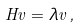<formula> <loc_0><loc_0><loc_500><loc_500>H v = \lambda v \, ,</formula> 